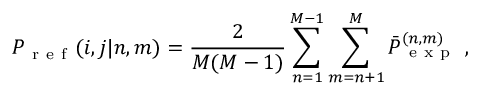<formula> <loc_0><loc_0><loc_500><loc_500>P _ { r e f } ( i , j | n , m ) = \frac { 2 } { M ( M - 1 ) } \sum _ { n = 1 } ^ { M - 1 } \sum _ { m = n + 1 } ^ { M } \bar { P } _ { e x p } ^ { ( n , m ) } ,</formula> 